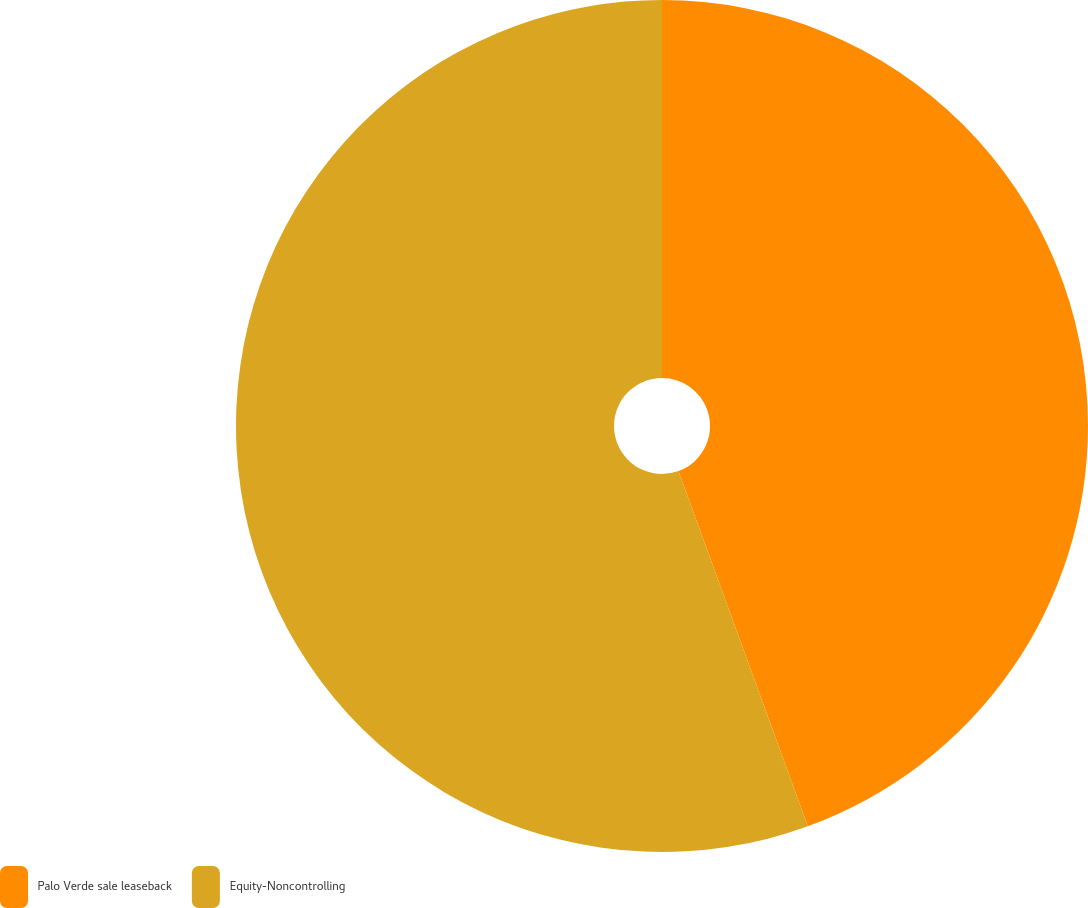<chart> <loc_0><loc_0><loc_500><loc_500><pie_chart><fcel>Palo Verde sale leaseback<fcel>Equity-Noncontrolling<nl><fcel>44.44%<fcel>55.56%<nl></chart> 